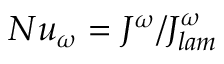Convert formula to latex. <formula><loc_0><loc_0><loc_500><loc_500>N u _ { \omega } = J ^ { \omega } / J _ { l a m } ^ { \omega }</formula> 